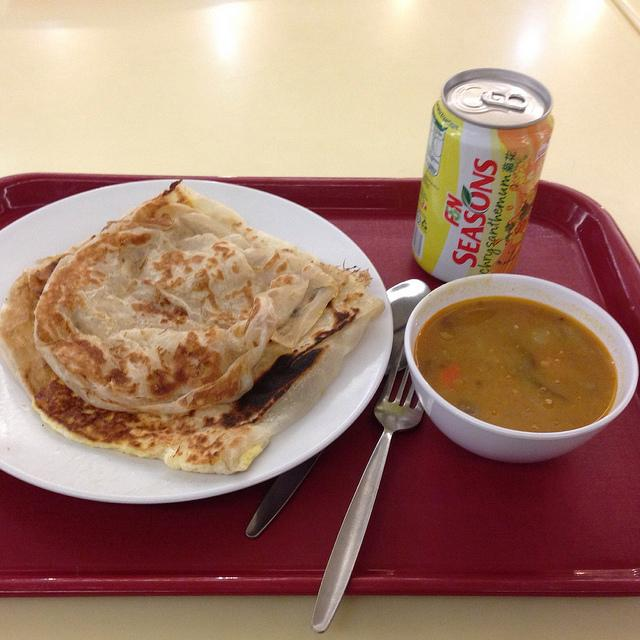Which item is probably the coldest? beverage 